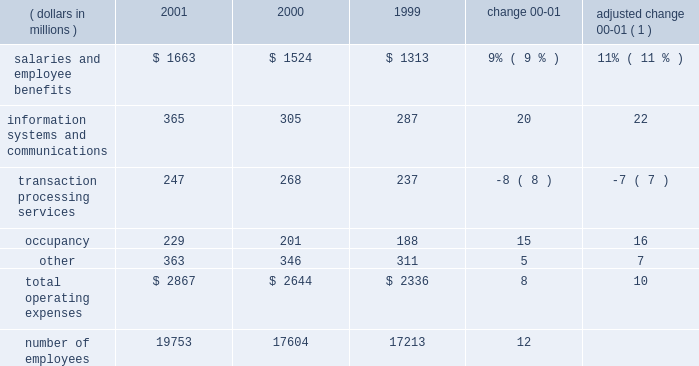Operating expenses operating expenses were $ 2.9 billion , an increase of 8% ( 8 % ) over 2000 .
Adjusted for the formation of citistreet , operating expenses grew 10% ( 10 % ) .
Expense growth in 2001 of 10% ( 10 % ) is significantly lower than the comparable 20% ( 20 % ) expense growth for 2000 compared to 1999 .
State street successfully reduced the growth rate of expenses as revenue growth slowed during the latter half of 2000 and early 2001 .
The expense growth in 2001 reflects higher expenses for salaries and employee benefits , as well as information systems and communications .
O p e r a t i n g e x p e n s e s ( dollars in millions ) 2001 2000 1999 change adjusted change 00-01 ( 1 ) .
( 1 ) 2000 results adjusted for the formation of citistreet expenses related to salaries and employee benefits increased $ 139million in 2001 , or $ 163millionwhen adjusted for the formation of citistreet .
The adjusted increase reflects more than 2100 additional staff to support the large client wins and new business from existing clients and acquisitions .
This expense increase was partially offset by lower incentive-based compensation .
Information systems and communications expense was $ 365 million in 2001 , up 20% ( 20 % ) from the prior year .
Adjusted for the formation of citistreet , information systems and communications expense increased 22% ( 22 % ) .
This growth reflects both continuing investment in software and hardware , aswell as the technology costs associated with increased staffing levels .
Expenses related to transaction processing services were $ 247 million , down $ 21 million , or 8% ( 8 % ) .
These expenses are volume related and include external contract services , subcustodian fees , brokerage services and fees related to securities settlement .
Lower mutual fund shareholder activities , and lower subcustodian fees resulting from both the decline in asset values and lower transaction volumes , drove the decline .
Occupancy expensewas $ 229million , up 15% ( 15 % ) .
The increase is due to expenses necessary to support state street 2019s global growth , and expenses incurred for leasehold improvements and other operational costs .
Other expenses were $ 363 million , up $ 17 million , or 5% ( 5 % ) .
These expenses include professional services , advertising and sales promotion , and internal operational expenses .
The increase over prior year is due to a $ 21 million increase in the amortization of goodwill , primarily from acquisitions in 2001 .
In accordance with recent accounting pronouncements , goodwill amortization expense will be eliminated in 2002 .
State street recorded approximately $ 38 million , or $ .08 per share after tax , of goodwill amortization expense in 2001 .
State street 2019s cost containment efforts , which reduced discretionary spending , partially offset the increase in other expenses .
State street corporation 9 .
What is the growth rate in the number of employees from 1999 to 2000? 
Computations: ((17604 - 17213) / 17213)
Answer: 0.02272. 